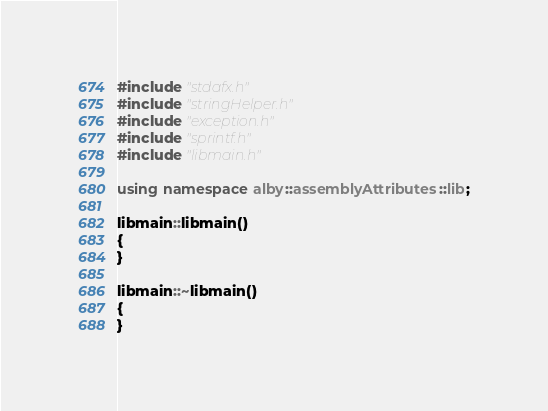Convert code to text. <code><loc_0><loc_0><loc_500><loc_500><_C++_>#include "stdafx.h"
#include "stringHelper.h"
#include "exception.h"
#include "sprintf.h"
#include "libmain.h"

using namespace alby::assemblyAttributes::lib;

libmain::libmain()
{
}

libmain::~libmain()
{
}

</code> 